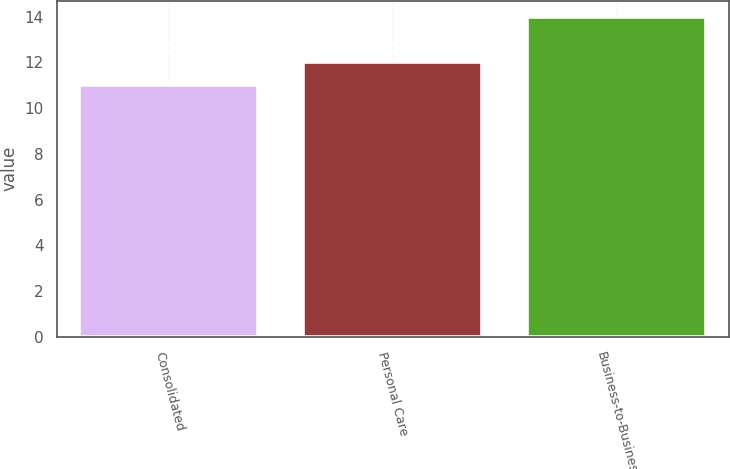Convert chart to OTSL. <chart><loc_0><loc_0><loc_500><loc_500><bar_chart><fcel>Consolidated<fcel>Personal Care<fcel>Business-to-Business<nl><fcel>11<fcel>12<fcel>14<nl></chart> 